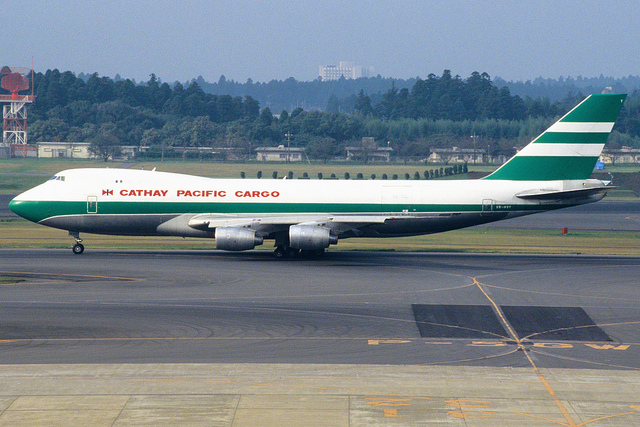<image>What ratio is the plane to the car? It is unknown the ratio of the plane to the car. It can be anywhere from 10:1 to 200:1. What ratio is the plane to the car? I don't know the ratio of the plane to the car. It can be larger, 10:1, or 200:1. 